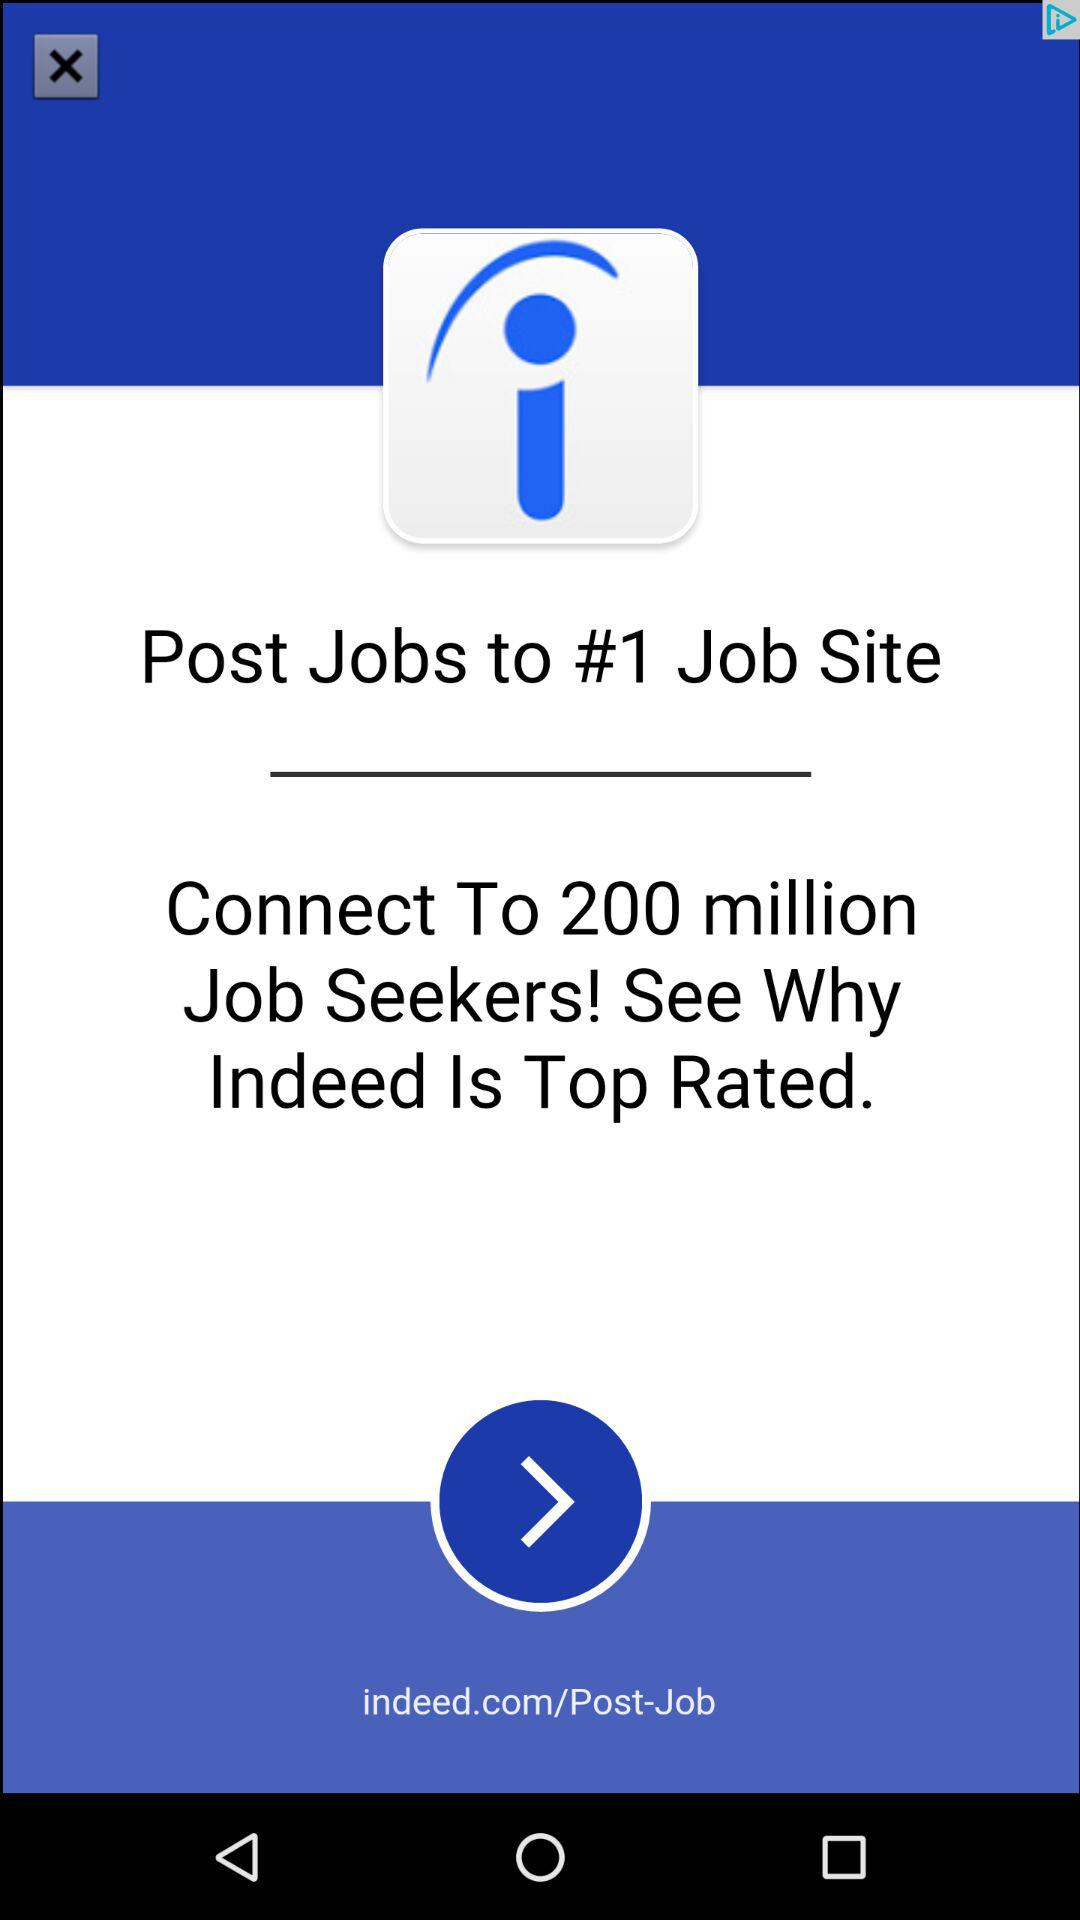How many million people are connected to job seekers? There are 200 million people connected to job seekers. 